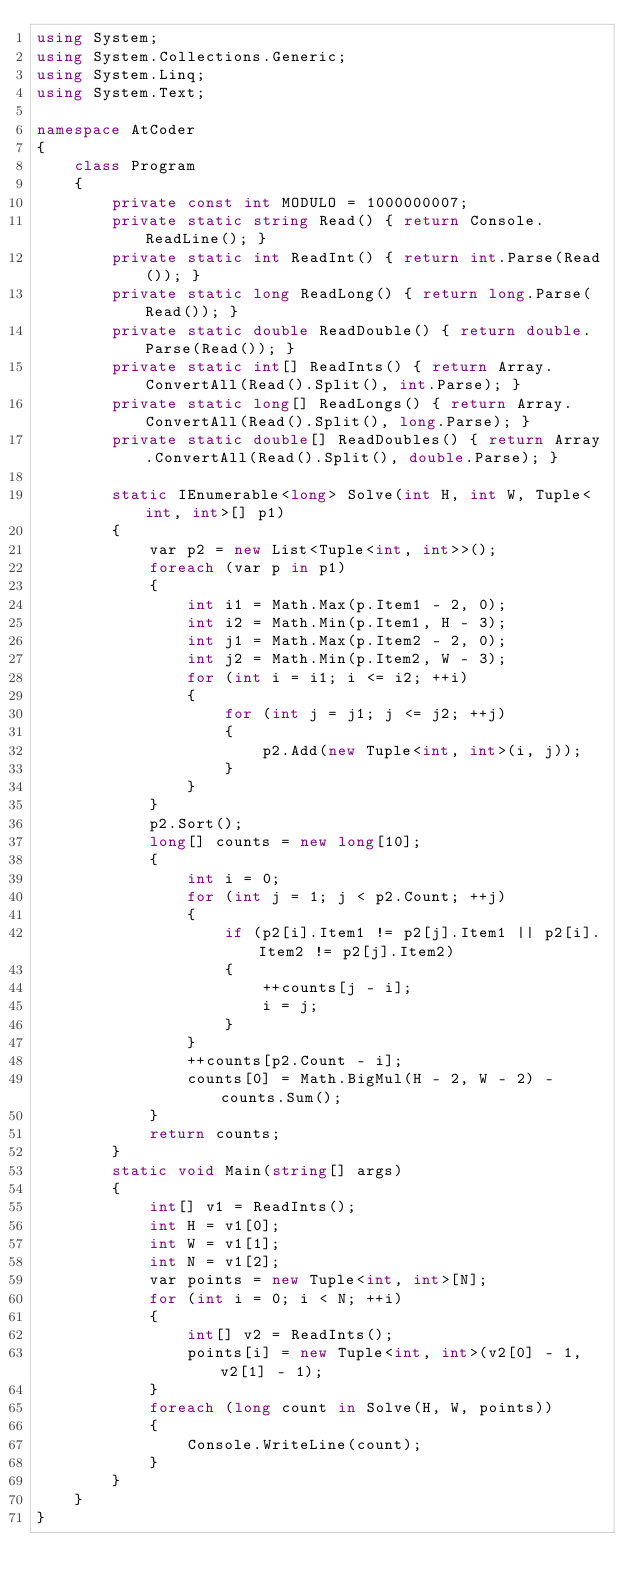<code> <loc_0><loc_0><loc_500><loc_500><_C#_>using System;
using System.Collections.Generic;
using System.Linq;
using System.Text;

namespace AtCoder
{
    class Program
    {
        private const int MODULO = 1000000007;
        private static string Read() { return Console.ReadLine(); }
        private static int ReadInt() { return int.Parse(Read()); }
        private static long ReadLong() { return long.Parse(Read()); }
        private static double ReadDouble() { return double.Parse(Read()); }
        private static int[] ReadInts() { return Array.ConvertAll(Read().Split(), int.Parse); }
        private static long[] ReadLongs() { return Array.ConvertAll(Read().Split(), long.Parse); }
        private static double[] ReadDoubles() { return Array.ConvertAll(Read().Split(), double.Parse); }

        static IEnumerable<long> Solve(int H, int W, Tuple<int, int>[] p1)
        {
            var p2 = new List<Tuple<int, int>>();
            foreach (var p in p1)
            {
                int i1 = Math.Max(p.Item1 - 2, 0);
                int i2 = Math.Min(p.Item1, H - 3);
                int j1 = Math.Max(p.Item2 - 2, 0);
                int j2 = Math.Min(p.Item2, W - 3);
                for (int i = i1; i <= i2; ++i)
                {
                    for (int j = j1; j <= j2; ++j)
                    {
                        p2.Add(new Tuple<int, int>(i, j));
                    }
                }
            }
            p2.Sort();
            long[] counts = new long[10];
            {
                int i = 0;
                for (int j = 1; j < p2.Count; ++j)
                {
                    if (p2[i].Item1 != p2[j].Item1 || p2[i].Item2 != p2[j].Item2)
                    {
                        ++counts[j - i];
                        i = j;
                    }
                }
                ++counts[p2.Count - i];
                counts[0] = Math.BigMul(H - 2, W - 2) - counts.Sum();
            }
            return counts;
        }
        static void Main(string[] args)
        {
            int[] v1 = ReadInts();
            int H = v1[0];
            int W = v1[1];
            int N = v1[2];
            var points = new Tuple<int, int>[N];
            for (int i = 0; i < N; ++i)
            {
                int[] v2 = ReadInts();
                points[i] = new Tuple<int, int>(v2[0] - 1, v2[1] - 1);
            }
            foreach (long count in Solve(H, W, points))
            {
                Console.WriteLine(count);
            }
        }
    }
}
</code> 